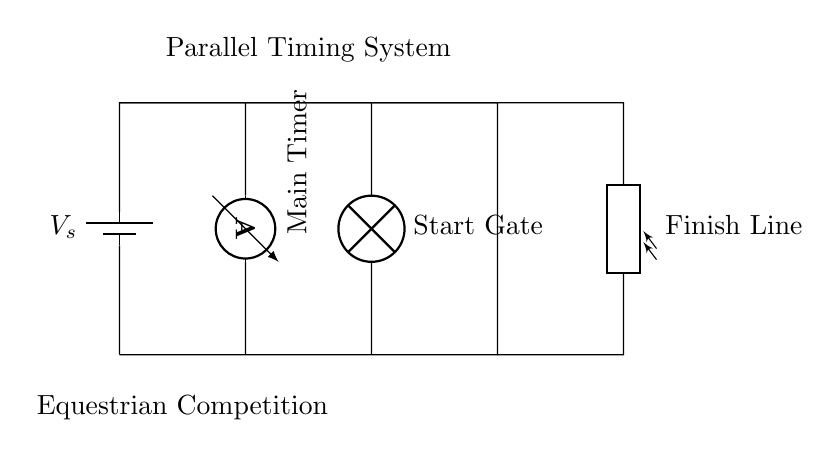What is the main component in the circuit? The main component is the main timer represented by the ammeter, which is essential for determining the timing in the equestrian competition.
Answer: Main Timer How many components are connected in parallel in this circuit? The circuit has three main components connected in parallel: the main timer, start gate, and finish line (photoresistor). This is determined by observing the branches that all connect to the same voltage supply without being in series with each other.
Answer: Three What role does the photoresistor play in this circuit? The photoresistor acts as the finish line detector, providing a way to track when a participant crosses the finish line by detecting light changes, which is crucial in timing systems.
Answer: Finish Line What happens when the start gate is activated? When the start gate is activated, it completes the circuit allowing current to flow to the main timer and finish line; thus, it signals the start of timing for the equestrian competition.
Answer: Timing Starts Calculate the total current in the circuit if each branch draws 2 Amperes. When components are in parallel, the total current is the sum of the currents in each branch. In this case, 2 Amperes from the main timer + 2 Amperes from the start gate + 2 Amperes from the finish line results in 6 Amperes total.
Answer: Six Amperes What is the purpose of the battery in this circuit? The battery serves as the voltage source (V_s), providing the necessary electrical energy to power the timing system and enable it to function correctly during the equestrian competition.
Answer: Voltage Source What do the wires connecting the components signify? The wires signify electrical connections between components, allowing current to flow throughout the circuit and ensuring all parts work together to track timing effectively.
Answer: Electrical Connections 